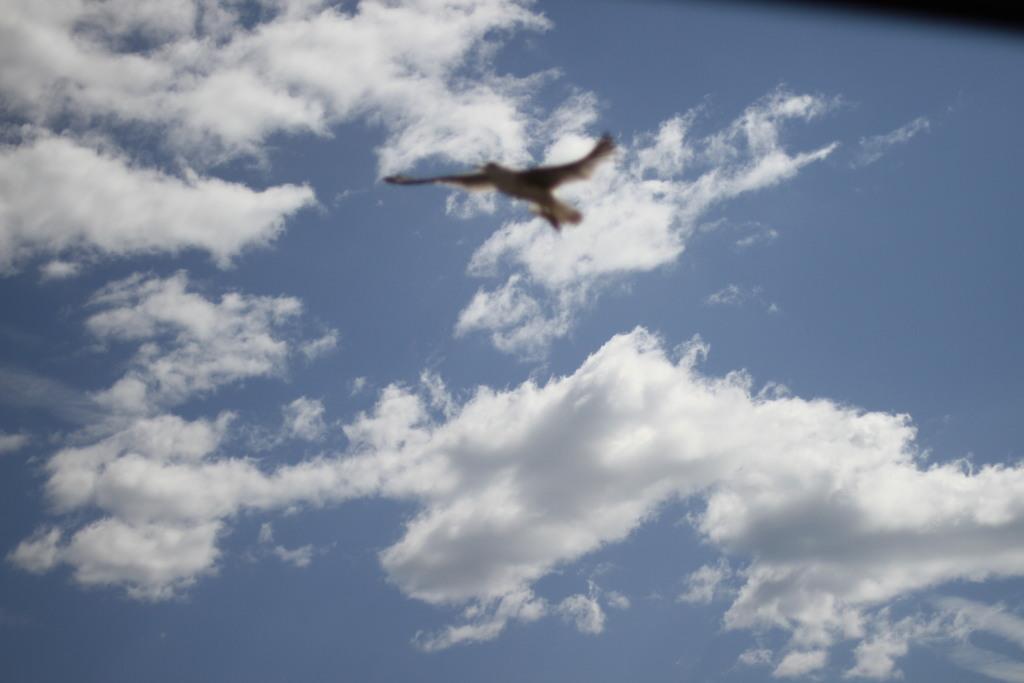How would you summarize this image in a sentence or two? This image is taken outdoors. In this image there is a sky with clouds. In the middle of the image a bird is flying in the sky. 